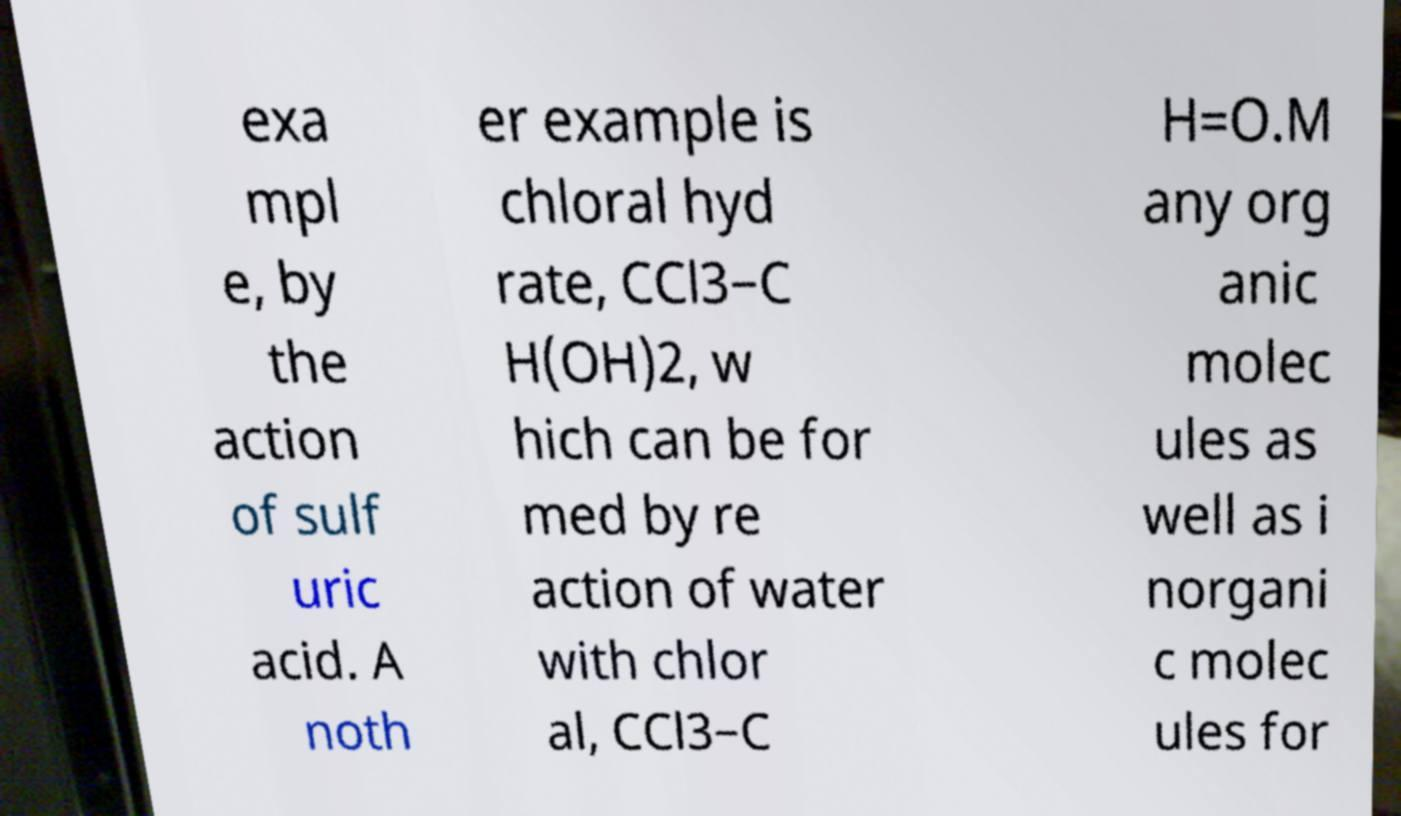There's text embedded in this image that I need extracted. Can you transcribe it verbatim? exa mpl e, by the action of sulf uric acid. A noth er example is chloral hyd rate, CCl3−C H(OH)2, w hich can be for med by re action of water with chlor al, CCl3−C H=O.M any org anic molec ules as well as i norgani c molec ules for 